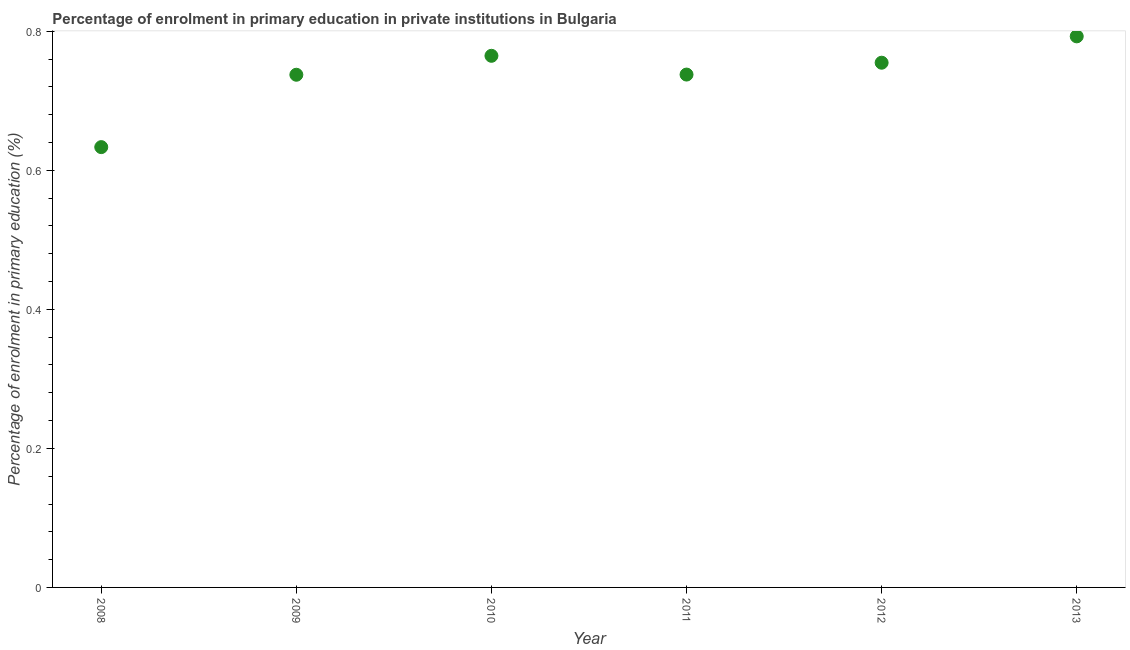What is the enrolment percentage in primary education in 2008?
Give a very brief answer. 0.63. Across all years, what is the maximum enrolment percentage in primary education?
Your response must be concise. 0.79. Across all years, what is the minimum enrolment percentage in primary education?
Keep it short and to the point. 0.63. In which year was the enrolment percentage in primary education maximum?
Your answer should be compact. 2013. In which year was the enrolment percentage in primary education minimum?
Keep it short and to the point. 2008. What is the sum of the enrolment percentage in primary education?
Your response must be concise. 4.42. What is the difference between the enrolment percentage in primary education in 2009 and 2013?
Keep it short and to the point. -0.06. What is the average enrolment percentage in primary education per year?
Your answer should be very brief. 0.74. What is the median enrolment percentage in primary education?
Your answer should be very brief. 0.75. In how many years, is the enrolment percentage in primary education greater than 0.7200000000000001 %?
Offer a terse response. 5. Do a majority of the years between 2011 and 2008 (inclusive) have enrolment percentage in primary education greater than 0.24000000000000002 %?
Provide a succinct answer. Yes. What is the ratio of the enrolment percentage in primary education in 2009 to that in 2011?
Your answer should be very brief. 1. Is the difference between the enrolment percentage in primary education in 2009 and 2013 greater than the difference between any two years?
Your answer should be compact. No. What is the difference between the highest and the second highest enrolment percentage in primary education?
Make the answer very short. 0.03. What is the difference between the highest and the lowest enrolment percentage in primary education?
Your response must be concise. 0.16. Does the enrolment percentage in primary education monotonically increase over the years?
Provide a short and direct response. No. How many dotlines are there?
Give a very brief answer. 1. Does the graph contain any zero values?
Your response must be concise. No. Does the graph contain grids?
Your response must be concise. No. What is the title of the graph?
Keep it short and to the point. Percentage of enrolment in primary education in private institutions in Bulgaria. What is the label or title of the X-axis?
Offer a very short reply. Year. What is the label or title of the Y-axis?
Ensure brevity in your answer.  Percentage of enrolment in primary education (%). What is the Percentage of enrolment in primary education (%) in 2008?
Your answer should be very brief. 0.63. What is the Percentage of enrolment in primary education (%) in 2009?
Provide a short and direct response. 0.74. What is the Percentage of enrolment in primary education (%) in 2010?
Offer a terse response. 0.76. What is the Percentage of enrolment in primary education (%) in 2011?
Provide a succinct answer. 0.74. What is the Percentage of enrolment in primary education (%) in 2012?
Your answer should be compact. 0.75. What is the Percentage of enrolment in primary education (%) in 2013?
Your response must be concise. 0.79. What is the difference between the Percentage of enrolment in primary education (%) in 2008 and 2009?
Your answer should be compact. -0.1. What is the difference between the Percentage of enrolment in primary education (%) in 2008 and 2010?
Provide a short and direct response. -0.13. What is the difference between the Percentage of enrolment in primary education (%) in 2008 and 2011?
Give a very brief answer. -0.1. What is the difference between the Percentage of enrolment in primary education (%) in 2008 and 2012?
Provide a succinct answer. -0.12. What is the difference between the Percentage of enrolment in primary education (%) in 2008 and 2013?
Keep it short and to the point. -0.16. What is the difference between the Percentage of enrolment in primary education (%) in 2009 and 2010?
Provide a short and direct response. -0.03. What is the difference between the Percentage of enrolment in primary education (%) in 2009 and 2011?
Your response must be concise. -0. What is the difference between the Percentage of enrolment in primary education (%) in 2009 and 2012?
Offer a terse response. -0.02. What is the difference between the Percentage of enrolment in primary education (%) in 2009 and 2013?
Give a very brief answer. -0.06. What is the difference between the Percentage of enrolment in primary education (%) in 2010 and 2011?
Your response must be concise. 0.03. What is the difference between the Percentage of enrolment in primary education (%) in 2010 and 2012?
Ensure brevity in your answer.  0.01. What is the difference between the Percentage of enrolment in primary education (%) in 2010 and 2013?
Provide a short and direct response. -0.03. What is the difference between the Percentage of enrolment in primary education (%) in 2011 and 2012?
Ensure brevity in your answer.  -0.02. What is the difference between the Percentage of enrolment in primary education (%) in 2011 and 2013?
Ensure brevity in your answer.  -0.05. What is the difference between the Percentage of enrolment in primary education (%) in 2012 and 2013?
Provide a short and direct response. -0.04. What is the ratio of the Percentage of enrolment in primary education (%) in 2008 to that in 2009?
Your answer should be very brief. 0.86. What is the ratio of the Percentage of enrolment in primary education (%) in 2008 to that in 2010?
Your answer should be compact. 0.83. What is the ratio of the Percentage of enrolment in primary education (%) in 2008 to that in 2011?
Keep it short and to the point. 0.86. What is the ratio of the Percentage of enrolment in primary education (%) in 2008 to that in 2012?
Make the answer very short. 0.84. What is the ratio of the Percentage of enrolment in primary education (%) in 2008 to that in 2013?
Keep it short and to the point. 0.8. What is the ratio of the Percentage of enrolment in primary education (%) in 2009 to that in 2011?
Make the answer very short. 1. What is the ratio of the Percentage of enrolment in primary education (%) in 2009 to that in 2012?
Your answer should be compact. 0.98. What is the ratio of the Percentage of enrolment in primary education (%) in 2011 to that in 2012?
Provide a succinct answer. 0.98. What is the ratio of the Percentage of enrolment in primary education (%) in 2011 to that in 2013?
Give a very brief answer. 0.93. 